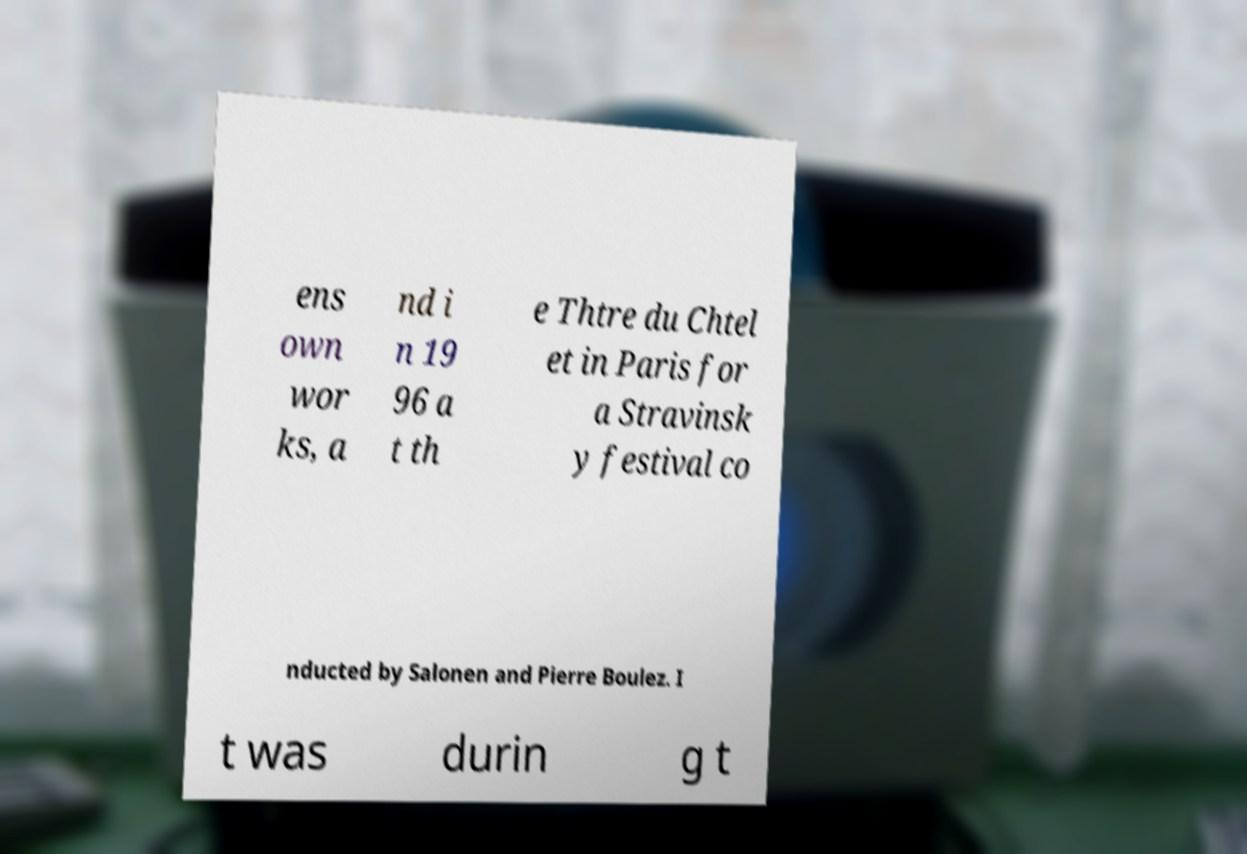For documentation purposes, I need the text within this image transcribed. Could you provide that? ens own wor ks, a nd i n 19 96 a t th e Thtre du Chtel et in Paris for a Stravinsk y festival co nducted by Salonen and Pierre Boulez. I t was durin g t 